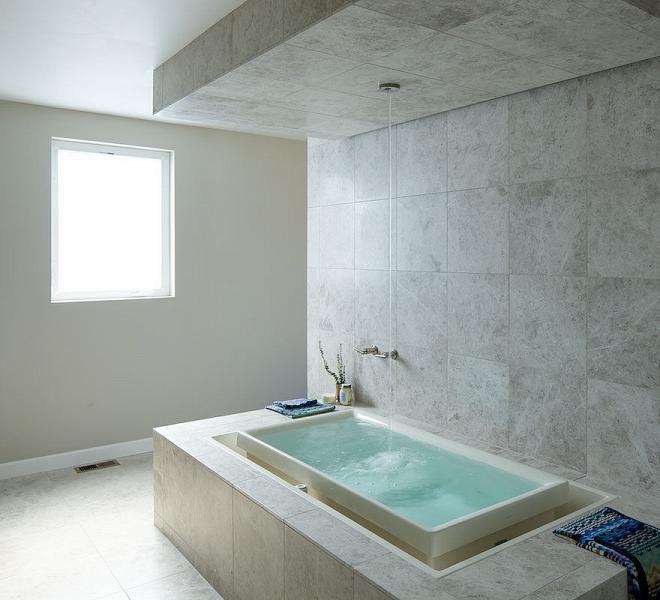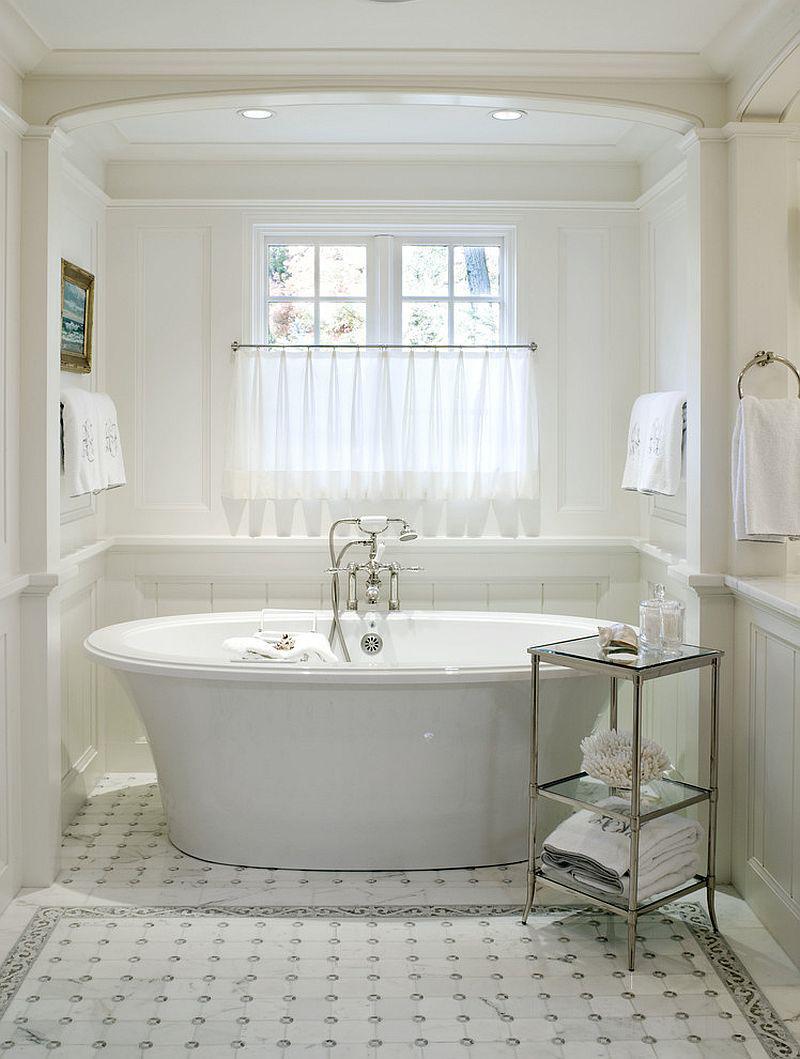The first image is the image on the left, the second image is the image on the right. Evaluate the accuracy of this statement regarding the images: "There are towels hanging on racks.". Is it true? Answer yes or no. Yes. The first image is the image on the left, the second image is the image on the right. Evaluate the accuracy of this statement regarding the images: "A light colored towel is draped over the side of a freestanding tub.". Is it true? Answer yes or no. No. 